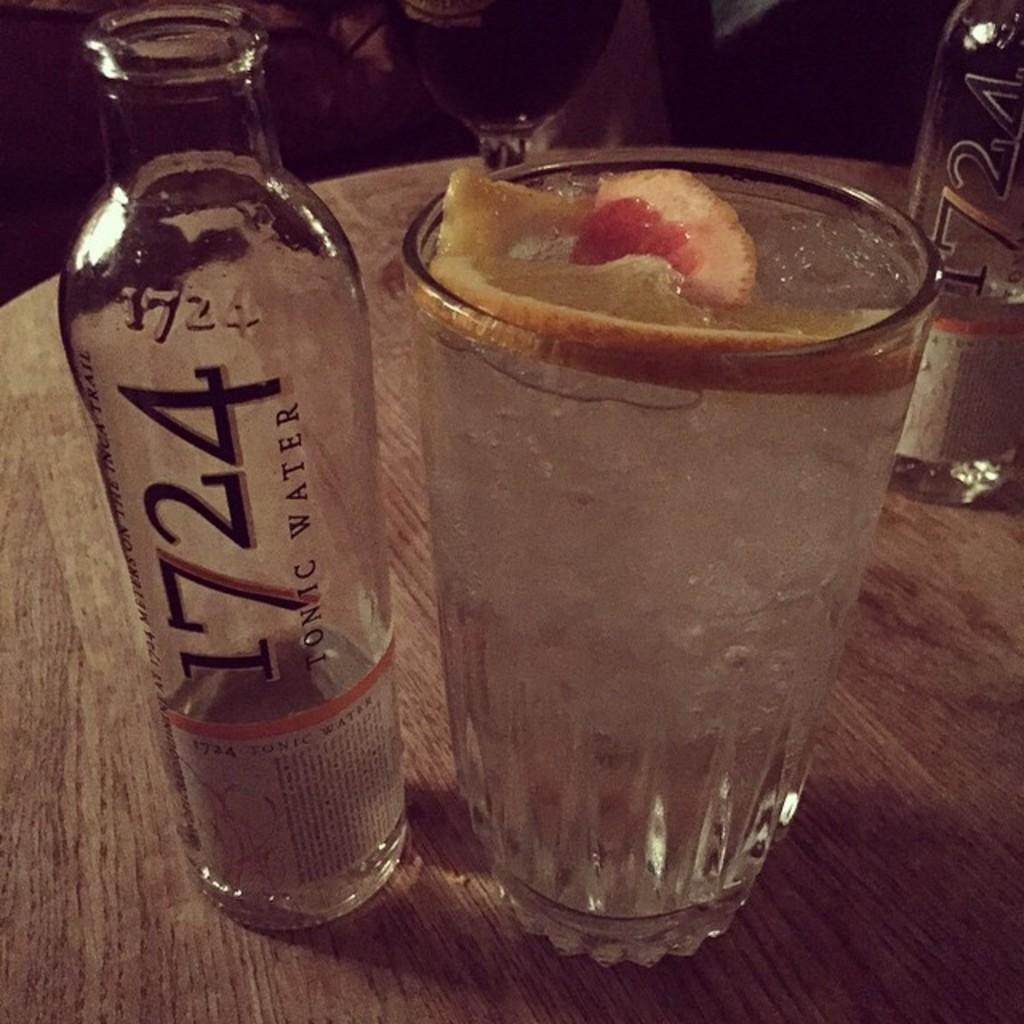<image>
Summarize the visual content of the image. A bottle of tonic water has the number 1724 on it. 